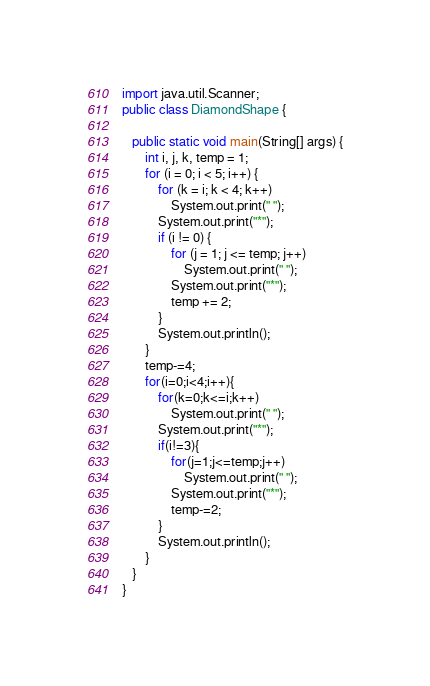<code> <loc_0><loc_0><loc_500><loc_500><_Java_>import java.util.Scanner;
public class DiamondShape {

   public static void main(String[] args) {
       int i, j, k, temp = 1;
       for (i = 0; i < 5; i++) {
           for (k = i; k < 4; k++)
               System.out.print(" ");
           System.out.print("*");
           if (i != 0) {
               for (j = 1; j <= temp; j++)
                   System.out.print(" ");
               System.out.print("*");
               temp += 2;
           }
           System.out.println();
       }
       temp-=4;
       for(i=0;i<4;i++){
           for(k=0;k<=i;k++)
               System.out.print(" ");
           System.out.print("*");
           if(i!=3){
               for(j=1;j<=temp;j++)
                   System.out.print(" ");
               System.out.print("*");
               temp-=2;
           }
           System.out.println();
       }
   }
}
</code> 